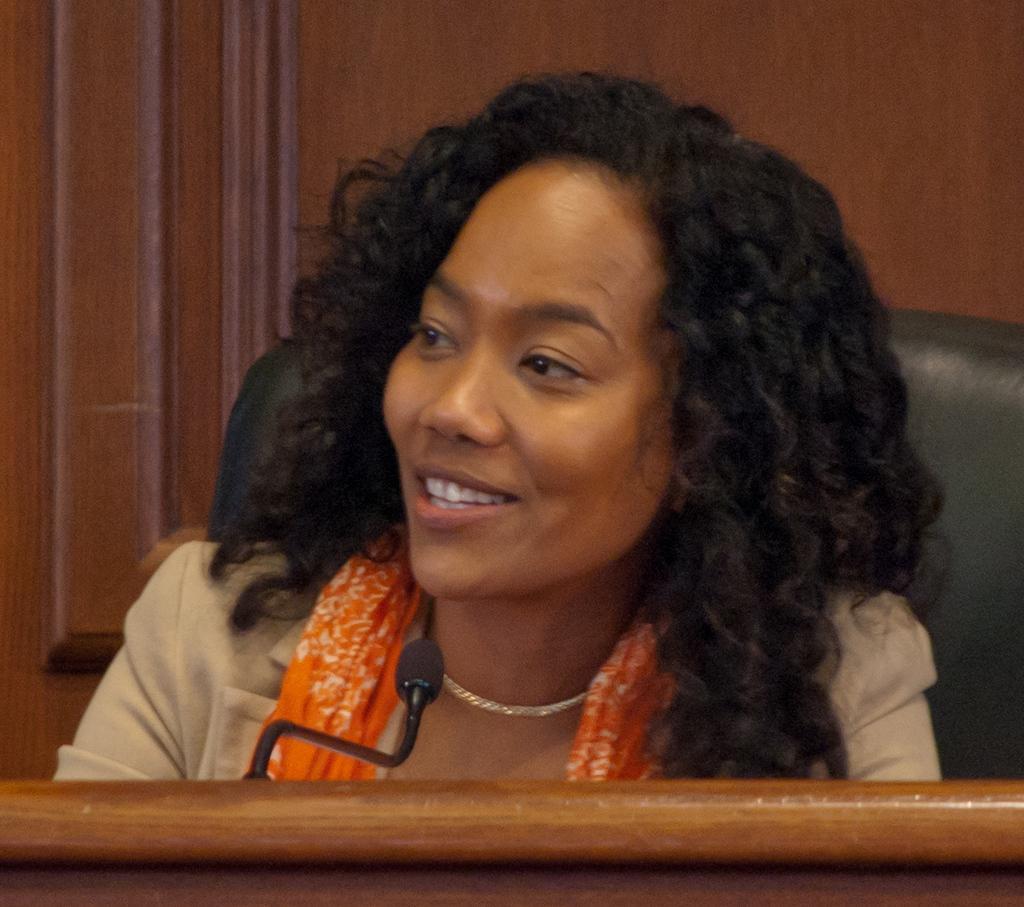Could you give a brief overview of what you see in this image? This image consists of a woman sitting in a chair. In front of the podium along with a mic. In the background, we can see a wooden wall. 